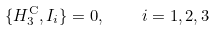<formula> <loc_0><loc_0><loc_500><loc_500>\{ H _ { 3 } ^ { \mathrm C } , I _ { i } \} = 0 , \quad i = 1 , 2 , 3</formula> 